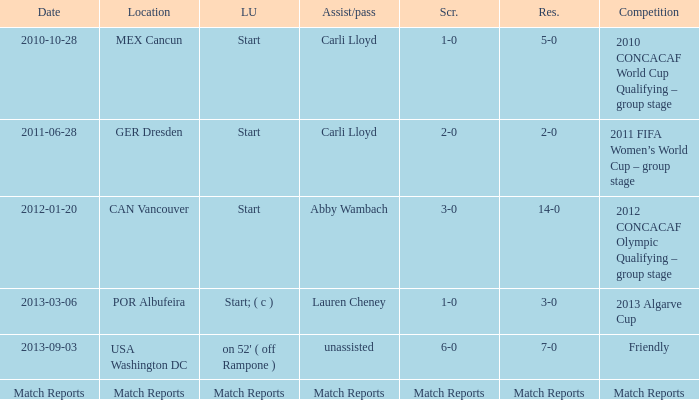Which score has a location of mex cancun? 1-0. 